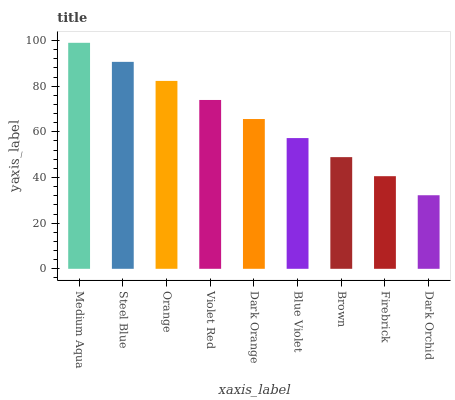Is Dark Orchid the minimum?
Answer yes or no. Yes. Is Medium Aqua the maximum?
Answer yes or no. Yes. Is Steel Blue the minimum?
Answer yes or no. No. Is Steel Blue the maximum?
Answer yes or no. No. Is Medium Aqua greater than Steel Blue?
Answer yes or no. Yes. Is Steel Blue less than Medium Aqua?
Answer yes or no. Yes. Is Steel Blue greater than Medium Aqua?
Answer yes or no. No. Is Medium Aqua less than Steel Blue?
Answer yes or no. No. Is Dark Orange the high median?
Answer yes or no. Yes. Is Dark Orange the low median?
Answer yes or no. Yes. Is Steel Blue the high median?
Answer yes or no. No. Is Dark Orchid the low median?
Answer yes or no. No. 